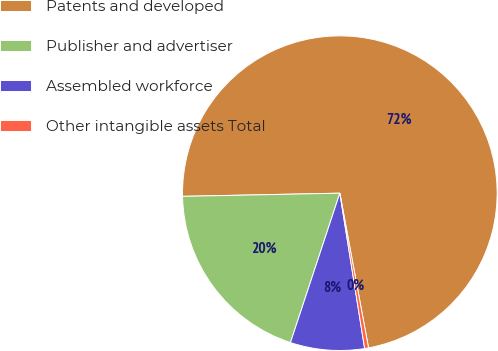Convert chart. <chart><loc_0><loc_0><loc_500><loc_500><pie_chart><fcel>Patents and developed<fcel>Publisher and advertiser<fcel>Assembled workforce<fcel>Other intangible assets Total<nl><fcel>72.4%<fcel>19.6%<fcel>7.6%<fcel>0.4%<nl></chart> 